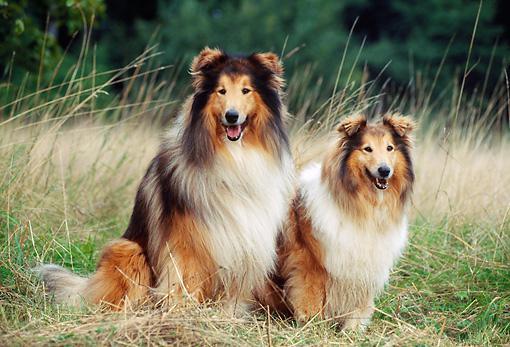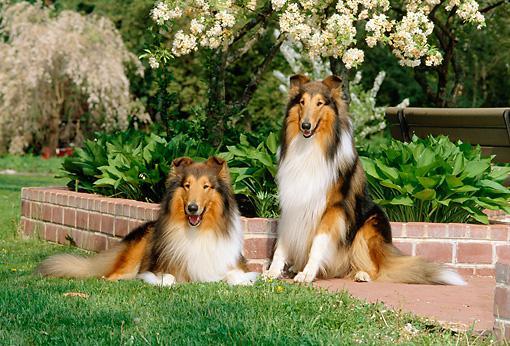The first image is the image on the left, the second image is the image on the right. Analyze the images presented: Is the assertion "There are four adult collies sitting next to each other." valid? Answer yes or no. Yes. The first image is the image on the left, the second image is the image on the right. Analyze the images presented: Is the assertion "An image shows exactly two collie dogs posed outdoors, with one reclining at the left of a dog sitting upright." valid? Answer yes or no. Yes. 